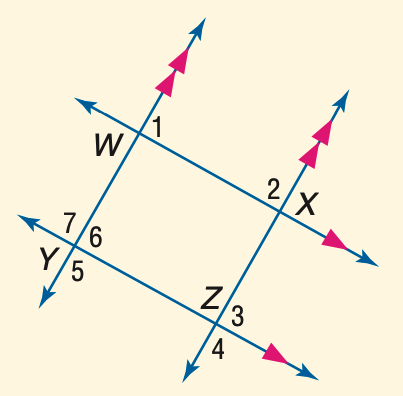Question: In the figure, m \angle 1 = 3 a + 40, m \angle 2 = 2 a + 25, and m \angle 3 = 5 b - 26. Find a.
Choices:
A. 23
B. 25
C. 27
D. 29
Answer with the letter. Answer: A Question: In the figure, m \angle 1 = 53. Find the measure of \angle 2.
Choices:
A. 97
B. 107
C. 117
D. 127
Answer with the letter. Answer: D Question: In the figure, m \angle 1 = 53. Find the measure of \angle 4.
Choices:
A. 113
B. 117
C. 123
D. 127
Answer with the letter. Answer: D Question: In the figure, m \angle 1 = 53. Find the measure of \angle 5.
Choices:
A. 113
B. 117
C. 123
D. 127
Answer with the letter. Answer: D Question: In the figure, m \angle 1 = 53. Find the measure of \angle 6.
Choices:
A. 53
B. 57
C. 63
D. 67
Answer with the letter. Answer: A Question: In the figure, m \angle 1 = 3 a + 40, m \angle 2 = 2 a + 25, and m \angle 3 = 5 b - 26. Find b.
Choices:
A. 21
B. 23
C. 25
D. 27
Answer with the letter. Answer: D Question: In the figure, m \angle 1 = 53. Find the measure of \angle 3.
Choices:
A. 53
B. 57
C. 63
D. 67
Answer with the letter. Answer: A 